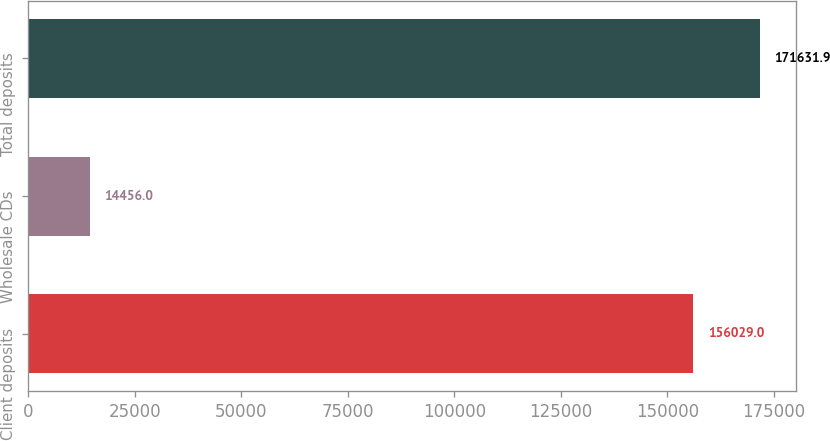Convert chart. <chart><loc_0><loc_0><loc_500><loc_500><bar_chart><fcel>Client deposits<fcel>Wholesale CDs<fcel>Total deposits<nl><fcel>156029<fcel>14456<fcel>171632<nl></chart> 